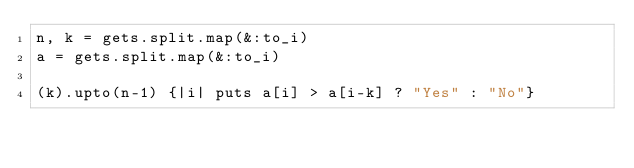Convert code to text. <code><loc_0><loc_0><loc_500><loc_500><_Ruby_>n, k = gets.split.map(&:to_i)
a = gets.split.map(&:to_i)

(k).upto(n-1) {|i| puts a[i] > a[i-k] ? "Yes" : "No"}</code> 